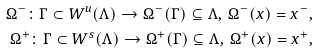<formula> <loc_0><loc_0><loc_500><loc_500>\Omega ^ { - } \colon \Gamma \subset W ^ { u } ( \Lambda ) \to \Omega ^ { - } ( \Gamma ) \subseteq \Lambda , \, \Omega ^ { - } ( x ) = x ^ { - } , \\ \Omega ^ { + } \colon \Gamma \subset W ^ { s } ( \Lambda ) \to \Omega ^ { + } ( \Gamma ) \subseteq \Lambda , \, \Omega ^ { + } ( x ) = x ^ { + } ,</formula> 